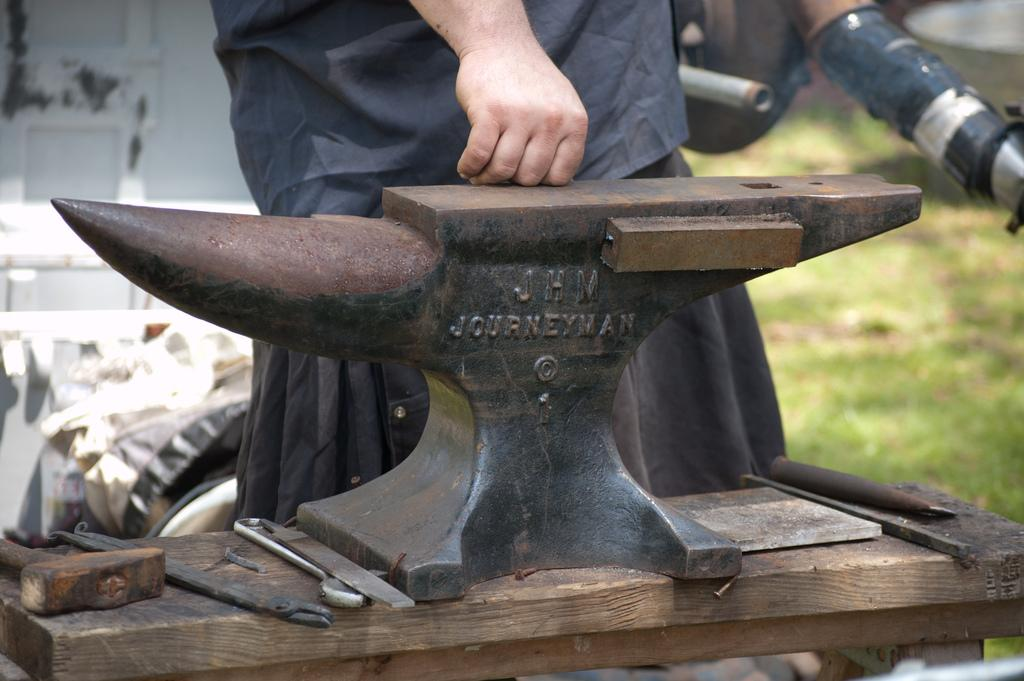What is the main subject of the image? There is a person standing in the image. What object can be seen near the person? There is an anvil in the image. What else is present in the image besides the person and the anvil? There are tools and other objects in the image. How many dogs are visible in the image? There are no dogs present in the image. What type of lumber is being used to construct the anvil in the image? The image does not show the construction of the anvil, nor does it depict any lumber. 